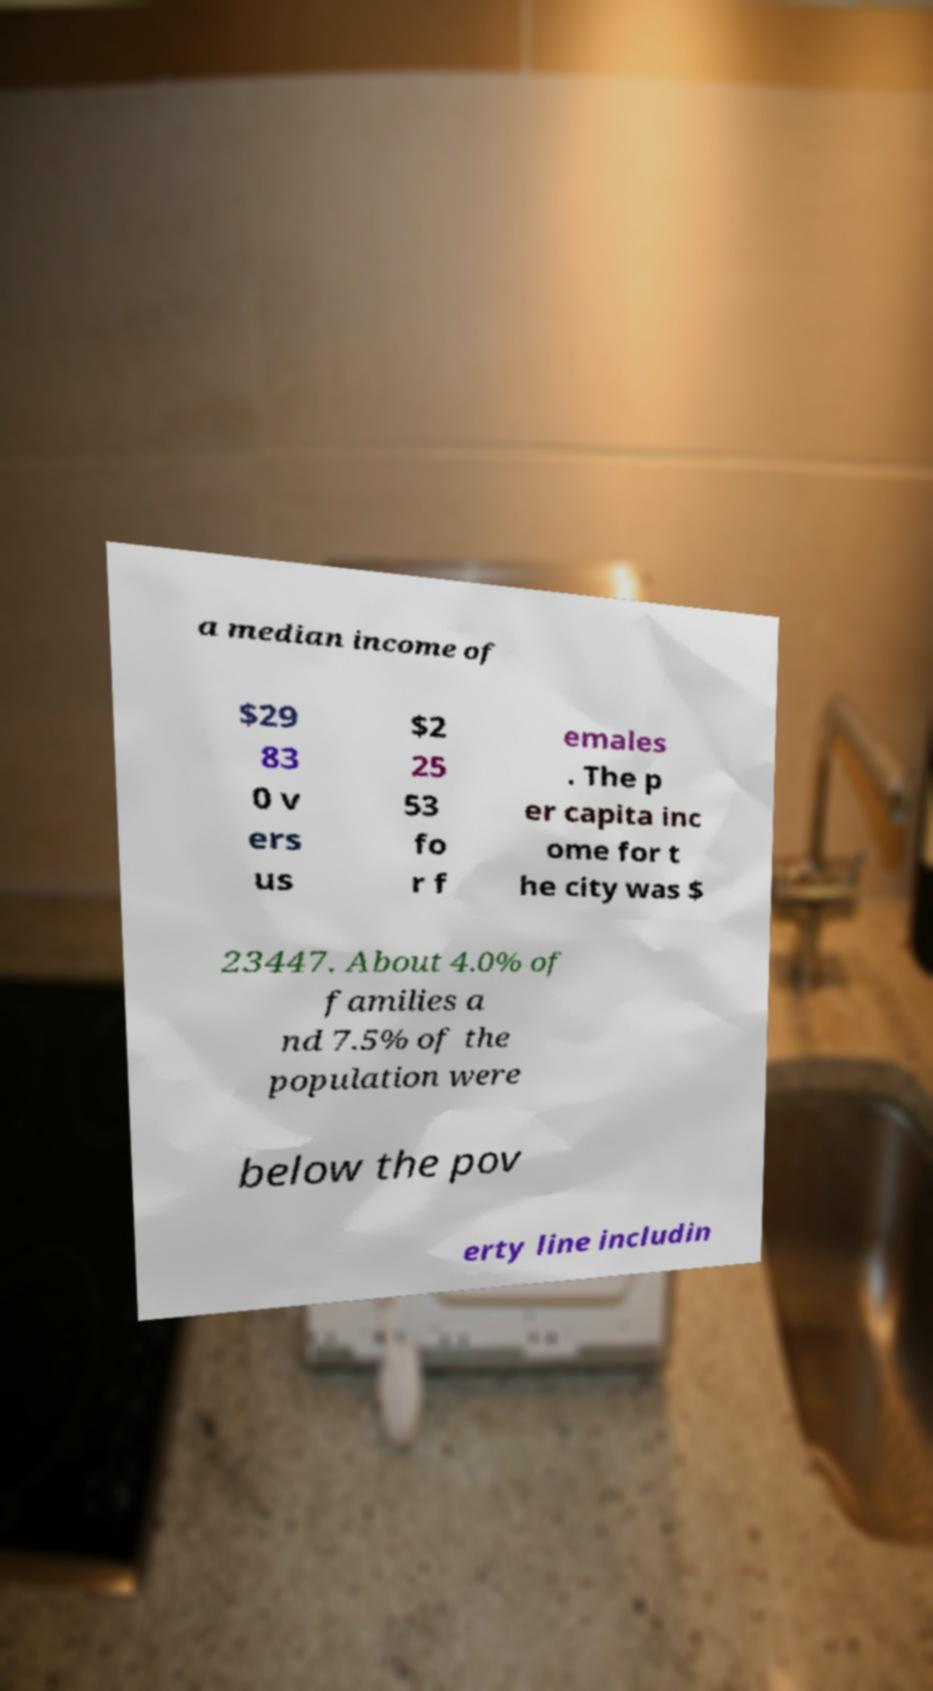Could you extract and type out the text from this image? a median income of $29 83 0 v ers us $2 25 53 fo r f emales . The p er capita inc ome for t he city was $ 23447. About 4.0% of families a nd 7.5% of the population were below the pov erty line includin 